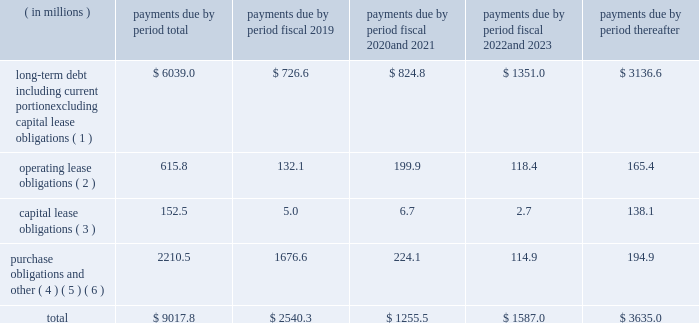Contractual obligations we summarize our enforceable and legally binding contractual obligations at september 30 , 2018 , and the effect these obligations are expected to have on our liquidity and cash flow in future periods in the table .
Certain amounts in this table are based on management fffds estimates and assumptions about these obligations , including their duration , the possibility of renewal , anticipated actions by third parties and other factors , including estimated minimum pension plan contributions and estimated benefit payments related to postretirement obligations , supplemental retirement plans and deferred compensation plans .
Because these estimates and assumptions are subjective , the enforceable and legally binding obligations we actually pay in future periods may vary from those presented in the table. .
( 1 ) includes only principal payments owed on our debt assuming that all of our long-term debt will be held to maturity , excluding scheduled payments .
We have excluded $ 205.2 million of fair value of debt step-up , deferred financing costs and unamortized bond discounts from the table to arrive at actual debt obligations .
See fffdnote 13 .
Debt fffd fffd of the notes to consolidated financial statements for information on the interest rates that apply to our various debt instruments .
( 2 ) see fffdnote 14 .
Operating leases fffd of the notes to consolidated financial statements for additional information .
( 3 ) the fair value step-up of $ 18.5 million is excluded .
See fffdnote 13 .
Debt fffd fffd capital lease and other indebtednesstt fffd of the notes to consolidated financial statements for additional information .
( 4 ) purchase obligations include agreements to purchase goods or services that are enforceable and legally binding and that specify all significant terms , including : fixed or minimum quantities to be purchased ; fixed , minimum or variable price provision ; and the approximate timing of the transaction .
Purchase obligations exclude agreements that are cancelable without penalty .
( 5 ) we have included in the table future estimated minimum pension plan contributions and estimated benefit payments related to postretirement obligations , supplemental retirement plans and deferred compensation plans .
Our estimates are based on factors , such as discount rates and expected returns on plan assets .
Future contributions are subject to changes in our underfunded status based on factors such as investment performance , discount rates , returns on plan assets and changes in legislation .
It is possible that our assumptions may change , actual market performance may vary or we may decide to contribute different amounts .
We have excluded $ 247.8 million of multiemployer pension plan withdrawal liabilities recorded as of september 30 , 2018 due to lack of definite payout terms for certain of the obligations .
See fffdnote 4 .
Retirement plans fffd multiemployer plans fffd of the notes to consolidated financial statements for additional information .
( 6 ) we have not included the following items in the table : fffd an item labeled fffdother long-term liabilities fffd reflected on our consolidated balance sheet because these liabilities do not have a definite pay-out scheme .
Fffd $ 158.4 million from the line item fffdpurchase obligations and other fffd for certain provisions of the financial accounting standards board fffds ( fffdfasb fffd ) accounting standards codification ( fffdasc fffd ) 740 , fffdincome taxes fffd associated with liabilities for uncertain tax positions due to the uncertainty as to the amount and timing of payment , if any .
In addition to the enforceable and legally binding obligations presented in the table above , we have other obligations for goods and services and raw materials entered into in the normal course of business .
These contracts , however , are subject to change based on our business decisions .
Expenditures for environmental compliance see item 1 .
Fffdbusiness fffd fffd governmental regulation fffd environmental and other matters fffd , fffdbusiness fffd fffd governmental regulation fffd cercla and other remediation costs fffd , and fffd fffdbusiness fffd fffd governmental regulation fffd climate change fffd for a discussion of our expenditures for environmental compliance. .
What percent of payments are differed until after 2023? 
Computations: (3635.0 / 9017.8)
Answer: 0.40309. Contractual obligations we summarize our enforceable and legally binding contractual obligations at september 30 , 2018 , and the effect these obligations are expected to have on our liquidity and cash flow in future periods in the table .
Certain amounts in this table are based on management fffds estimates and assumptions about these obligations , including their duration , the possibility of renewal , anticipated actions by third parties and other factors , including estimated minimum pension plan contributions and estimated benefit payments related to postretirement obligations , supplemental retirement plans and deferred compensation plans .
Because these estimates and assumptions are subjective , the enforceable and legally binding obligations we actually pay in future periods may vary from those presented in the table. .
( 1 ) includes only principal payments owed on our debt assuming that all of our long-term debt will be held to maturity , excluding scheduled payments .
We have excluded $ 205.2 million of fair value of debt step-up , deferred financing costs and unamortized bond discounts from the table to arrive at actual debt obligations .
See fffdnote 13 .
Debt fffd fffd of the notes to consolidated financial statements for information on the interest rates that apply to our various debt instruments .
( 2 ) see fffdnote 14 .
Operating leases fffd of the notes to consolidated financial statements for additional information .
( 3 ) the fair value step-up of $ 18.5 million is excluded .
See fffdnote 13 .
Debt fffd fffd capital lease and other indebtednesstt fffd of the notes to consolidated financial statements for additional information .
( 4 ) purchase obligations include agreements to purchase goods or services that are enforceable and legally binding and that specify all significant terms , including : fixed or minimum quantities to be purchased ; fixed , minimum or variable price provision ; and the approximate timing of the transaction .
Purchase obligations exclude agreements that are cancelable without penalty .
( 5 ) we have included in the table future estimated minimum pension plan contributions and estimated benefit payments related to postretirement obligations , supplemental retirement plans and deferred compensation plans .
Our estimates are based on factors , such as discount rates and expected returns on plan assets .
Future contributions are subject to changes in our underfunded status based on factors such as investment performance , discount rates , returns on plan assets and changes in legislation .
It is possible that our assumptions may change , actual market performance may vary or we may decide to contribute different amounts .
We have excluded $ 247.8 million of multiemployer pension plan withdrawal liabilities recorded as of september 30 , 2018 due to lack of definite payout terms for certain of the obligations .
See fffdnote 4 .
Retirement plans fffd multiemployer plans fffd of the notes to consolidated financial statements for additional information .
( 6 ) we have not included the following items in the table : fffd an item labeled fffdother long-term liabilities fffd reflected on our consolidated balance sheet because these liabilities do not have a definite pay-out scheme .
Fffd $ 158.4 million from the line item fffdpurchase obligations and other fffd for certain provisions of the financial accounting standards board fffds ( fffdfasb fffd ) accounting standards codification ( fffdasc fffd ) 740 , fffdincome taxes fffd associated with liabilities for uncertain tax positions due to the uncertainty as to the amount and timing of payment , if any .
In addition to the enforceable and legally binding obligations presented in the table above , we have other obligations for goods and services and raw materials entered into in the normal course of business .
These contracts , however , are subject to change based on our business decisions .
Expenditures for environmental compliance see item 1 .
Fffdbusiness fffd fffd governmental regulation fffd environmental and other matters fffd , fffdbusiness fffd fffd governmental regulation fffd cercla and other remediation costs fffd , and fffd fffdbusiness fffd fffd governmental regulation fffd climate change fffd for a discussion of our expenditures for environmental compliance. .
What percent of payments is longterm debt? 
Computations: (6039.0 / 9017.8)
Answer: 0.66968. 